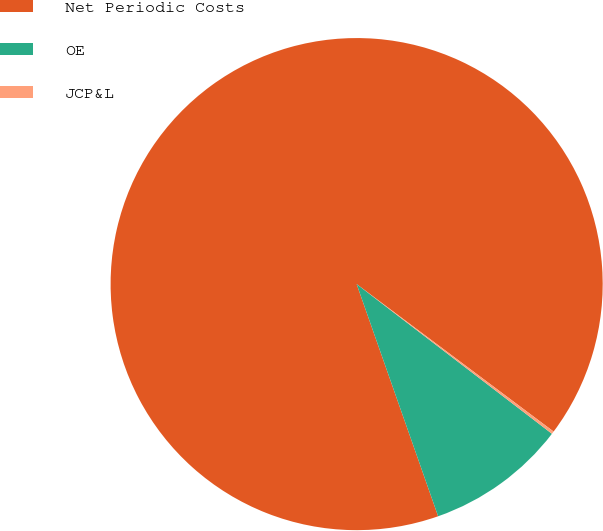<chart> <loc_0><loc_0><loc_500><loc_500><pie_chart><fcel>Net Periodic Costs<fcel>OE<fcel>JCP&L<nl><fcel>90.6%<fcel>9.22%<fcel>0.18%<nl></chart> 